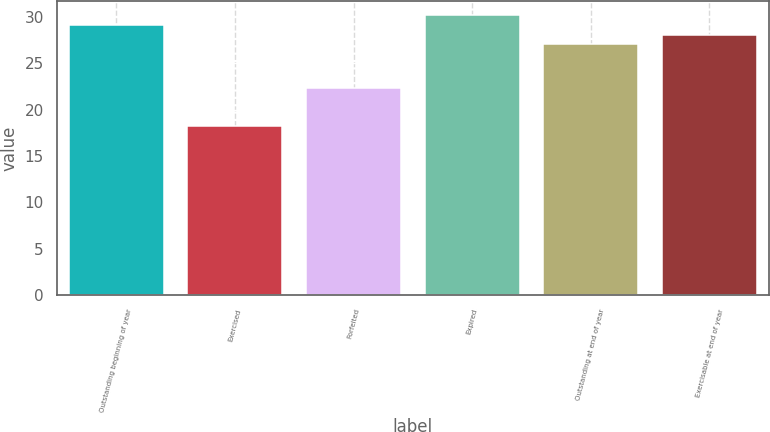<chart> <loc_0><loc_0><loc_500><loc_500><bar_chart><fcel>Outstanding beginning of year<fcel>Exercised<fcel>Forfeited<fcel>Expired<fcel>Outstanding at end of year<fcel>Exercisable at end of year<nl><fcel>29.15<fcel>18.28<fcel>22.28<fcel>30.2<fcel>27.05<fcel>28.1<nl></chart> 